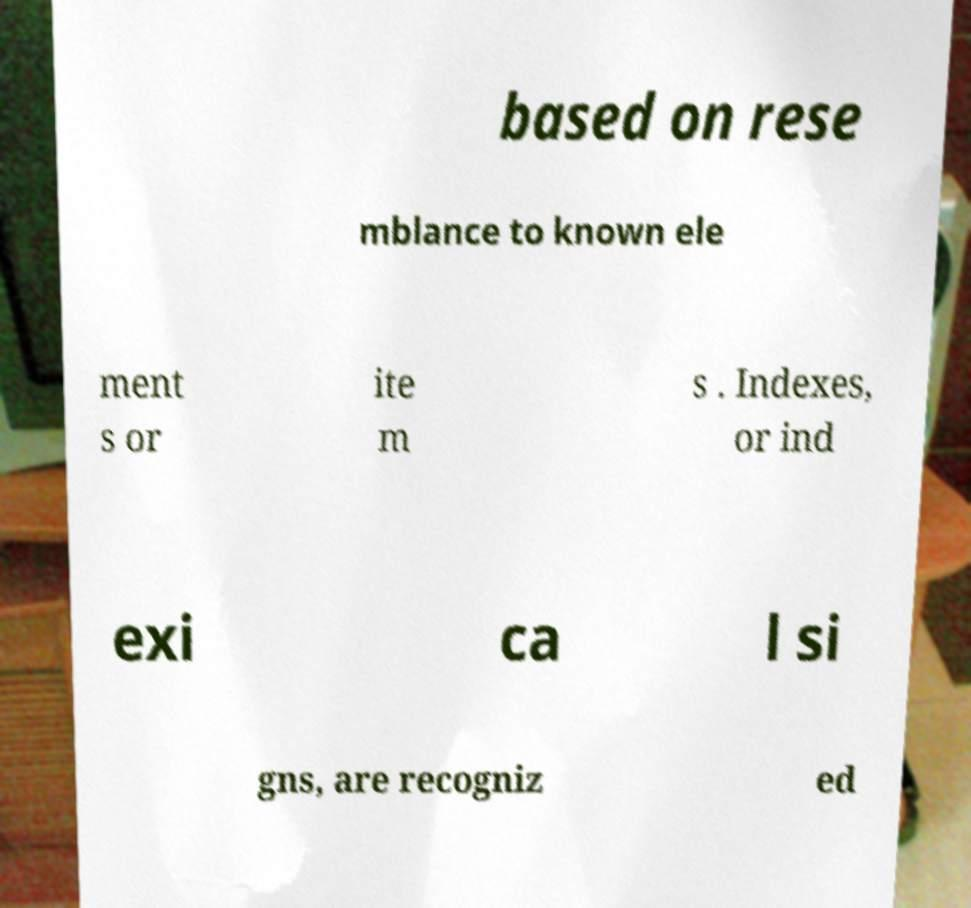There's text embedded in this image that I need extracted. Can you transcribe it verbatim? based on rese mblance to known ele ment s or ite m s . Indexes, or ind exi ca l si gns, are recogniz ed 